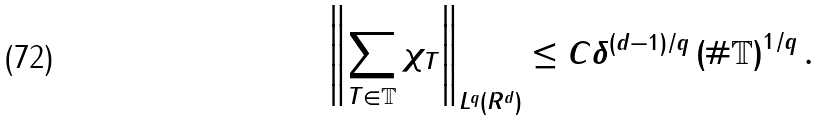<formula> <loc_0><loc_0><loc_500><loc_500>\left \| \sum _ { T \in \mathbb { T } } \chi _ { T } \right \| _ { L ^ { q } ( { R } ^ { d } ) } \leq C \delta ^ { ( d - 1 ) / q } \left ( \# \mathbb { T } \right ) ^ { 1 / q } .</formula> 